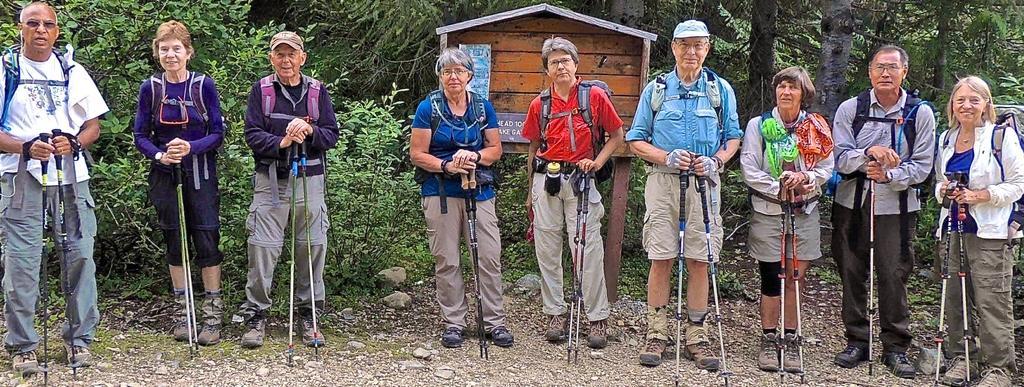Can you describe this image briefly? In this image, I can see few people standing and holding the trekking sticks. This looks like a board, which is attached to the poles. I can see the rocks. These are the trees with branches and leaves. 